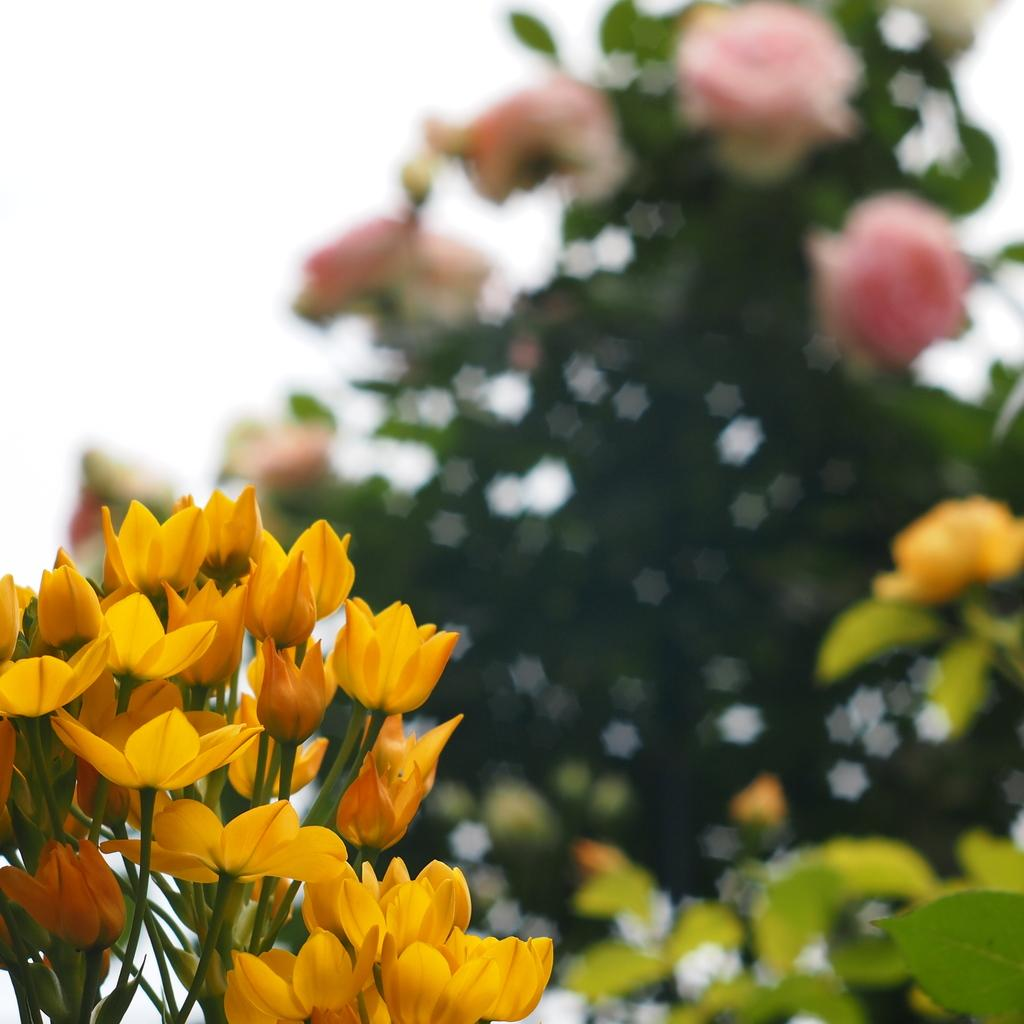What is the main subject in the front of the image? There is a flower plant in the front of the image. Can you describe the background of the image? The background of the image is blurry. How many pets are visible in the image? There are no pets present in the image. What type of bed can be seen in the image? There is no bed present in the image. 